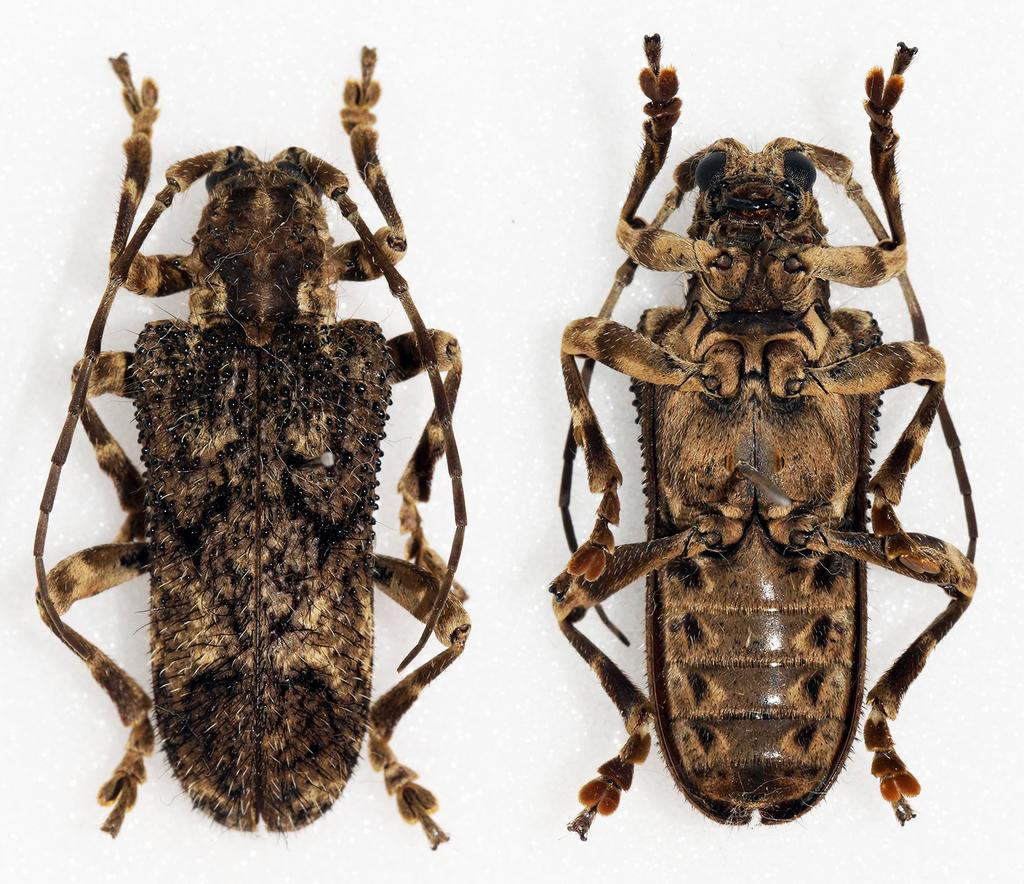What type of animals can be seen in the image? There are two cockroaches in the image. What type of sail can be seen on the cockroaches in the image? There are no sails present in the image, as it features cockroaches and not any objects with sails. 